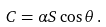Convert formula to latex. <formula><loc_0><loc_0><loc_500><loc_500>C = \alpha S \cos \theta \, .</formula> 